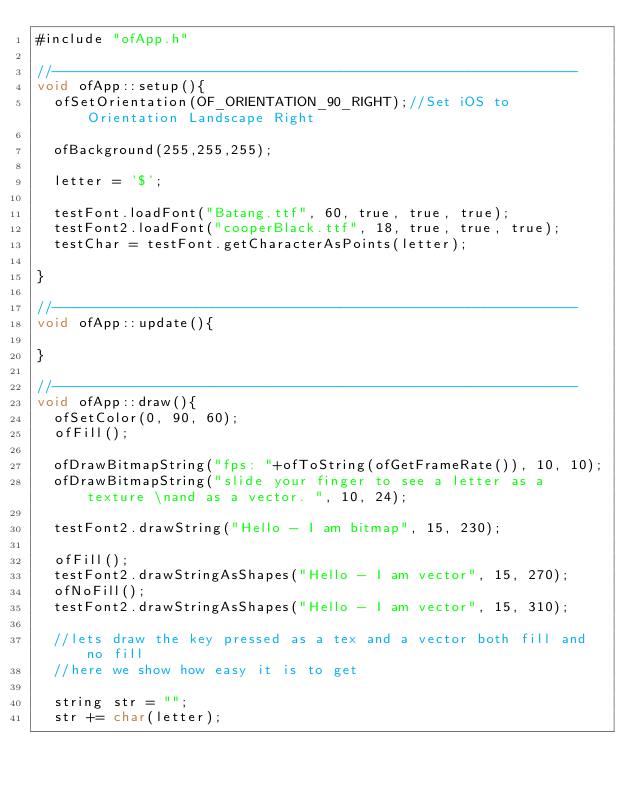<code> <loc_0><loc_0><loc_500><loc_500><_ObjectiveC_>#include "ofApp.h"

//--------------------------------------------------------------
void ofApp::setup(){	
	ofSetOrientation(OF_ORIENTATION_90_RIGHT);//Set iOS to Orientation Landscape Right
	
	ofBackground(255,255,255);	

	letter = '$';

	testFont.loadFont("Batang.ttf", 60, true, true, true);
	testFont2.loadFont("cooperBlack.ttf", 18, true, true, true);
	testChar = testFont.getCharacterAsPoints(letter);

}

//--------------------------------------------------------------
void ofApp::update(){
	
}

//--------------------------------------------------------------
void ofApp::draw(){
	ofSetColor(0, 90, 60);
	ofFill();

	ofDrawBitmapString("fps: "+ofToString(ofGetFrameRate()), 10, 10);
	ofDrawBitmapString("slide your finger to see a letter as a texture \nand as a vector. ", 10, 24);

	testFont2.drawString("Hello - I am bitmap", 15, 230);

	ofFill();
	testFont2.drawStringAsShapes("Hello - I am vector", 15, 270);
	ofNoFill();
	testFont2.drawStringAsShapes("Hello - I am vector", 15, 310);

	//lets draw the key pressed as a tex and a vector both fill and no fill
	//here we show how easy it is to get

	string str = "";
	str += char(letter);
</code> 